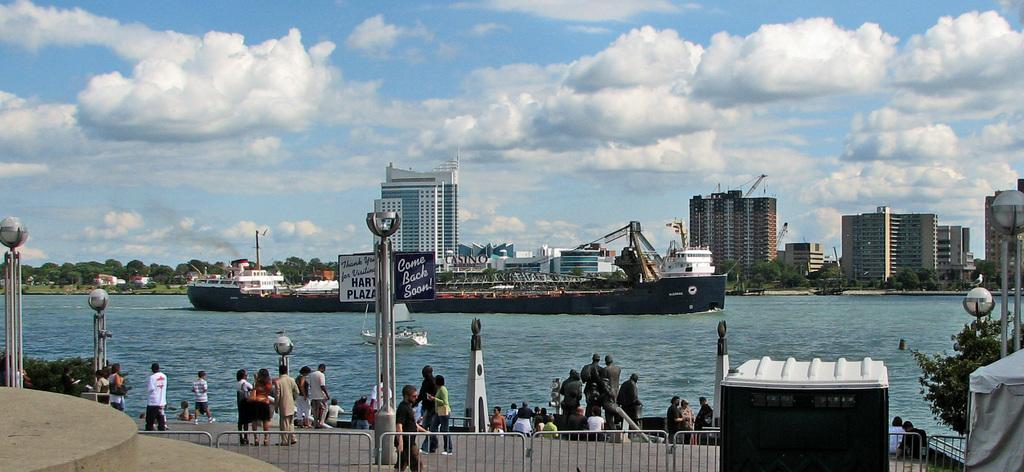What is the main subject in the water in the image? There is a big ship in the water. What are the people in the image doing? The people are standing and watching the ship. What can be seen in the background of the image? There are buildings visible in the image. What type of vegetation is present in the image? There are trees present in the image. Can you tell me how many owls are sitting on the ship in the image? There are no owls present on the ship in the image. What type of credit can be seen being given to the ship in the image? There is no credit being given to the ship in the image. 